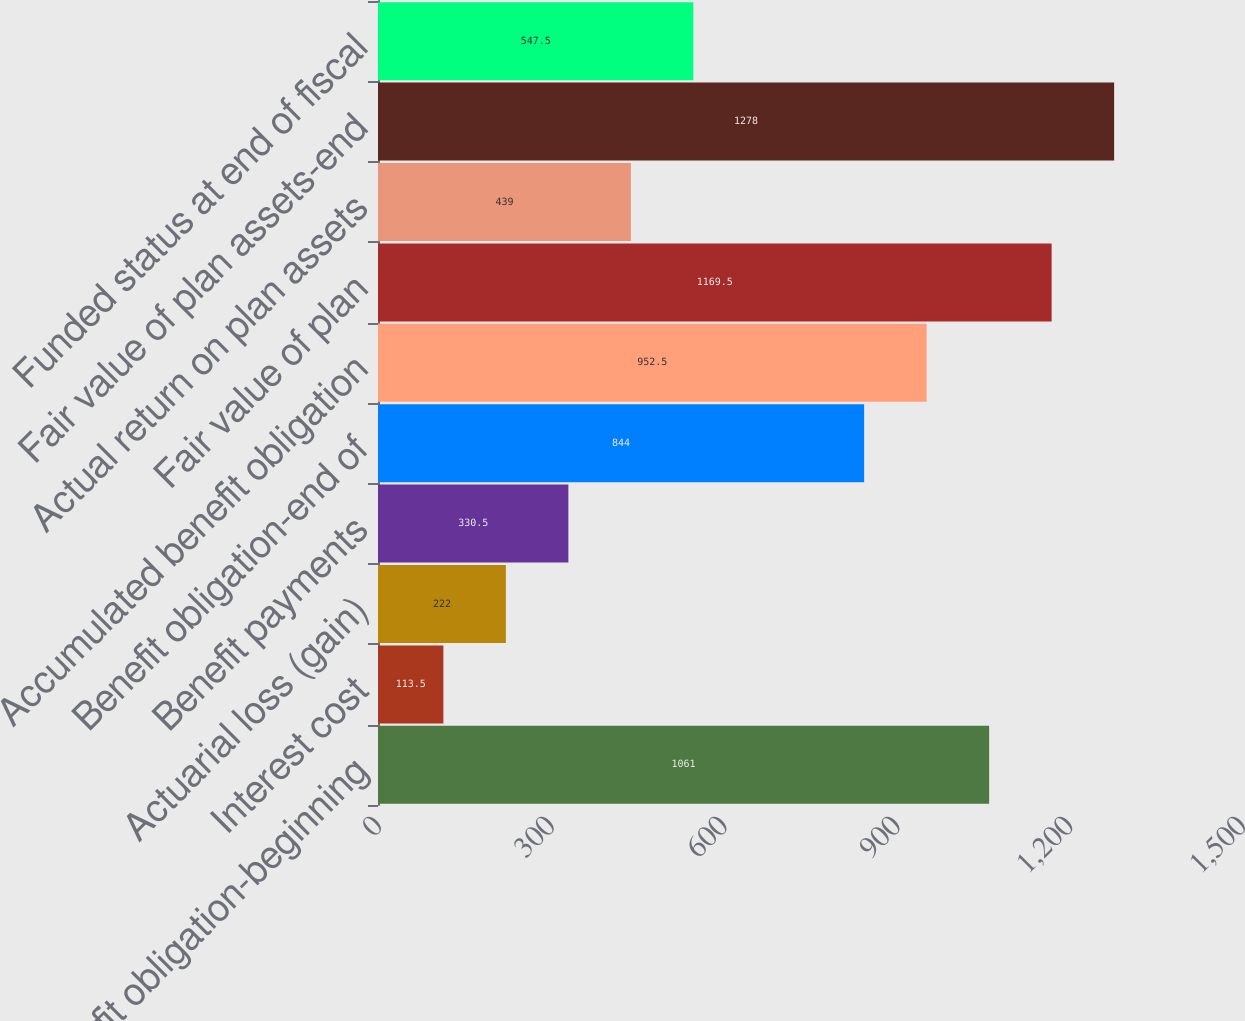Convert chart to OTSL. <chart><loc_0><loc_0><loc_500><loc_500><bar_chart><fcel>Benefit obligation-beginning<fcel>Interest cost<fcel>Actuarial loss (gain)<fcel>Benefit payments<fcel>Benefit obligation-end of<fcel>Accumulated benefit obligation<fcel>Fair value of plan<fcel>Actual return on plan assets<fcel>Fair value of plan assets-end<fcel>Funded status at end of fiscal<nl><fcel>1061<fcel>113.5<fcel>222<fcel>330.5<fcel>844<fcel>952.5<fcel>1169.5<fcel>439<fcel>1278<fcel>547.5<nl></chart> 